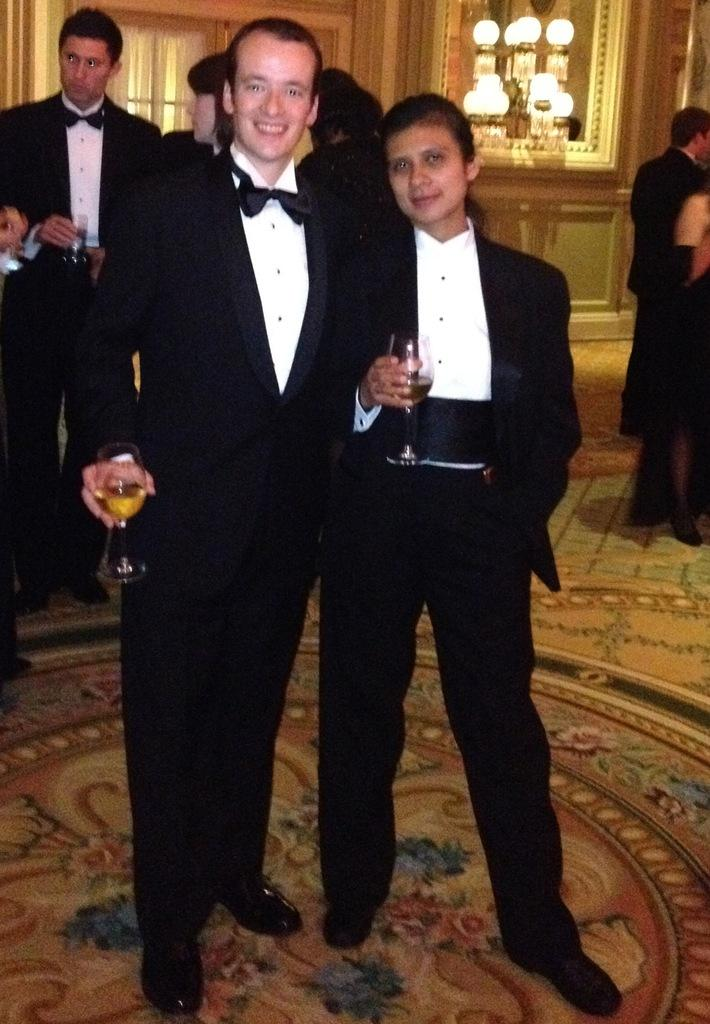What are the people in the image doing? The people in the image are standing and holding glasses of drink. What can be seen on the wall in the image? There is a window with a curtain on the wall in the image. What type of lighting is present in the image? Lights are visible in the image. What is the surface that the people are standing on in the image? The floor is present in the image. What hobbies do the people in the image have? There is no information about the hobbies of the people in the image. What type of vest is the person on the left wearing? There is no person on the left in the image, and no one is wearing a vest. 